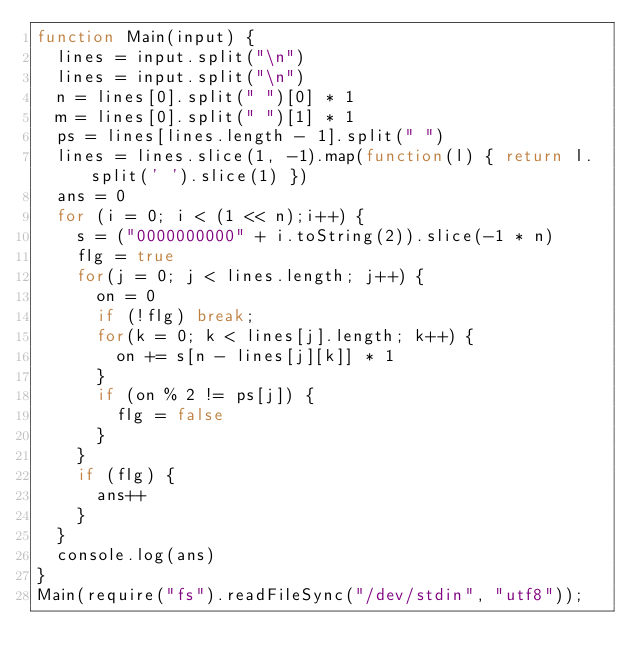Convert code to text. <code><loc_0><loc_0><loc_500><loc_500><_JavaScript_>function Main(input) {
  lines = input.split("\n")
  lines = input.split("\n")
  n = lines[0].split(" ")[0] * 1
  m = lines[0].split(" ")[1] * 1
  ps = lines[lines.length - 1].split(" ")
  lines = lines.slice(1, -1).map(function(l) { return l.split(' ').slice(1) })
  ans = 0
  for (i = 0; i < (1 << n);i++) {
    s = ("0000000000" + i.toString(2)).slice(-1 * n)
    flg = true
    for(j = 0; j < lines.length; j++) {
      on = 0
      if (!flg) break;
      for(k = 0; k < lines[j].length; k++) {
        on += s[n - lines[j][k]] * 1
      }
      if (on % 2 != ps[j]) {
        flg = false
      }
    }
    if (flg) {
      ans++
    }
  }
  console.log(ans) 
}
Main(require("fs").readFileSync("/dev/stdin", "utf8"));
</code> 